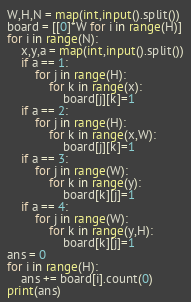Convert code to text. <code><loc_0><loc_0><loc_500><loc_500><_Python_>W,H,N = map(int,input().split())
board = [[0]*W for i in range(H)]
for i in range(N):
    x,y,a = map(int,input().split())
    if a == 1:
        for j in range(H):
            for k in range(x):
                board[j][k]=1
    if a == 2:
        for j in range(H):
            for k in range(x,W):
                board[j][k]=1
    if a == 3:
        for j in range(W):
            for k in range(y):
                board[k][j]=1
    if a == 4:
        for j in range(W):
            for k in range(y,H):
                board[k][j]=1
ans = 0
for i in range(H):
    ans += board[i].count(0)
print(ans)</code> 